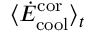<formula> <loc_0><loc_0><loc_500><loc_500>\langle \dot { E } _ { c o o l } ^ { c o r } \rangle _ { t }</formula> 